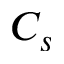Convert formula to latex. <formula><loc_0><loc_0><loc_500><loc_500>C _ { s }</formula> 